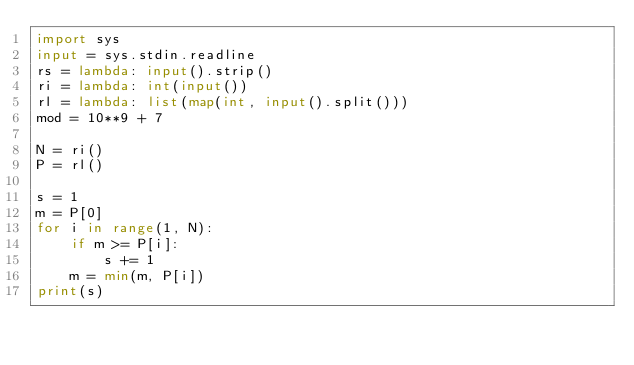<code> <loc_0><loc_0><loc_500><loc_500><_Python_>import sys
input = sys.stdin.readline
rs = lambda: input().strip()
ri = lambda: int(input())
rl = lambda: list(map(int, input().split()))
mod = 10**9 + 7

N = ri()
P = rl()

s = 1
m = P[0]
for i in range(1, N):
    if m >= P[i]:
        s += 1
    m = min(m, P[i])
print(s)</code> 